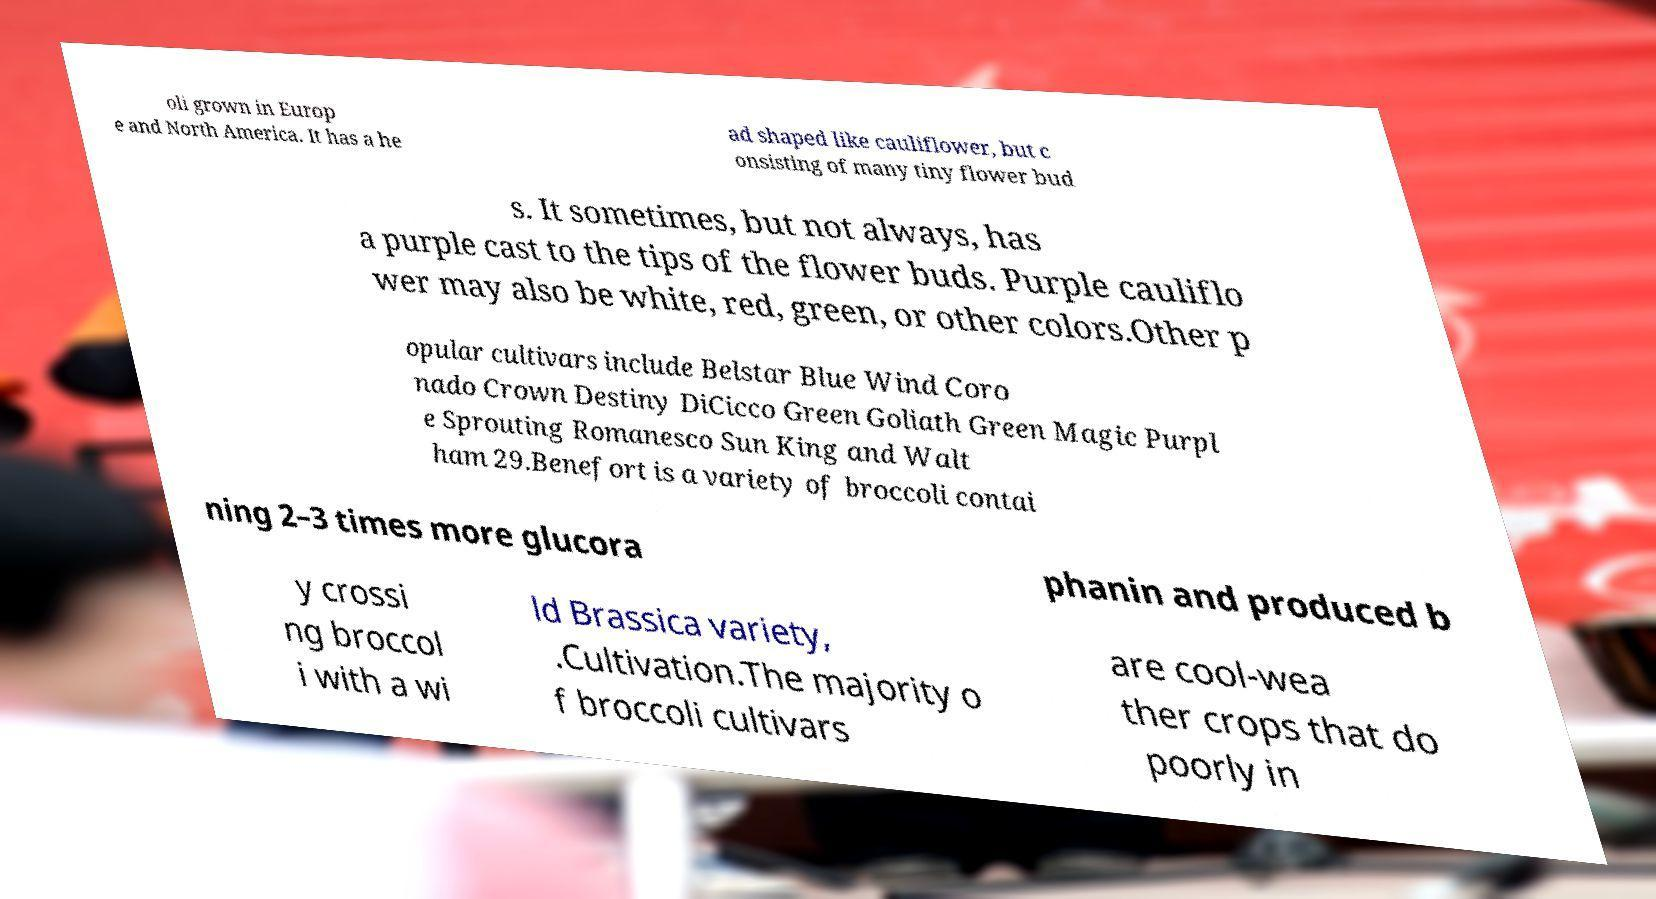What messages or text are displayed in this image? I need them in a readable, typed format. oli grown in Europ e and North America. It has a he ad shaped like cauliflower, but c onsisting of many tiny flower bud s. It sometimes, but not always, has a purple cast to the tips of the flower buds. Purple cauliflo wer may also be white, red, green, or other colors.Other p opular cultivars include Belstar Blue Wind Coro nado Crown Destiny DiCicco Green Goliath Green Magic Purpl e Sprouting Romanesco Sun King and Walt ham 29.Benefort is a variety of broccoli contai ning 2–3 times more glucora phanin and produced b y crossi ng broccol i with a wi ld Brassica variety, .Cultivation.The majority o f broccoli cultivars are cool-wea ther crops that do poorly in 